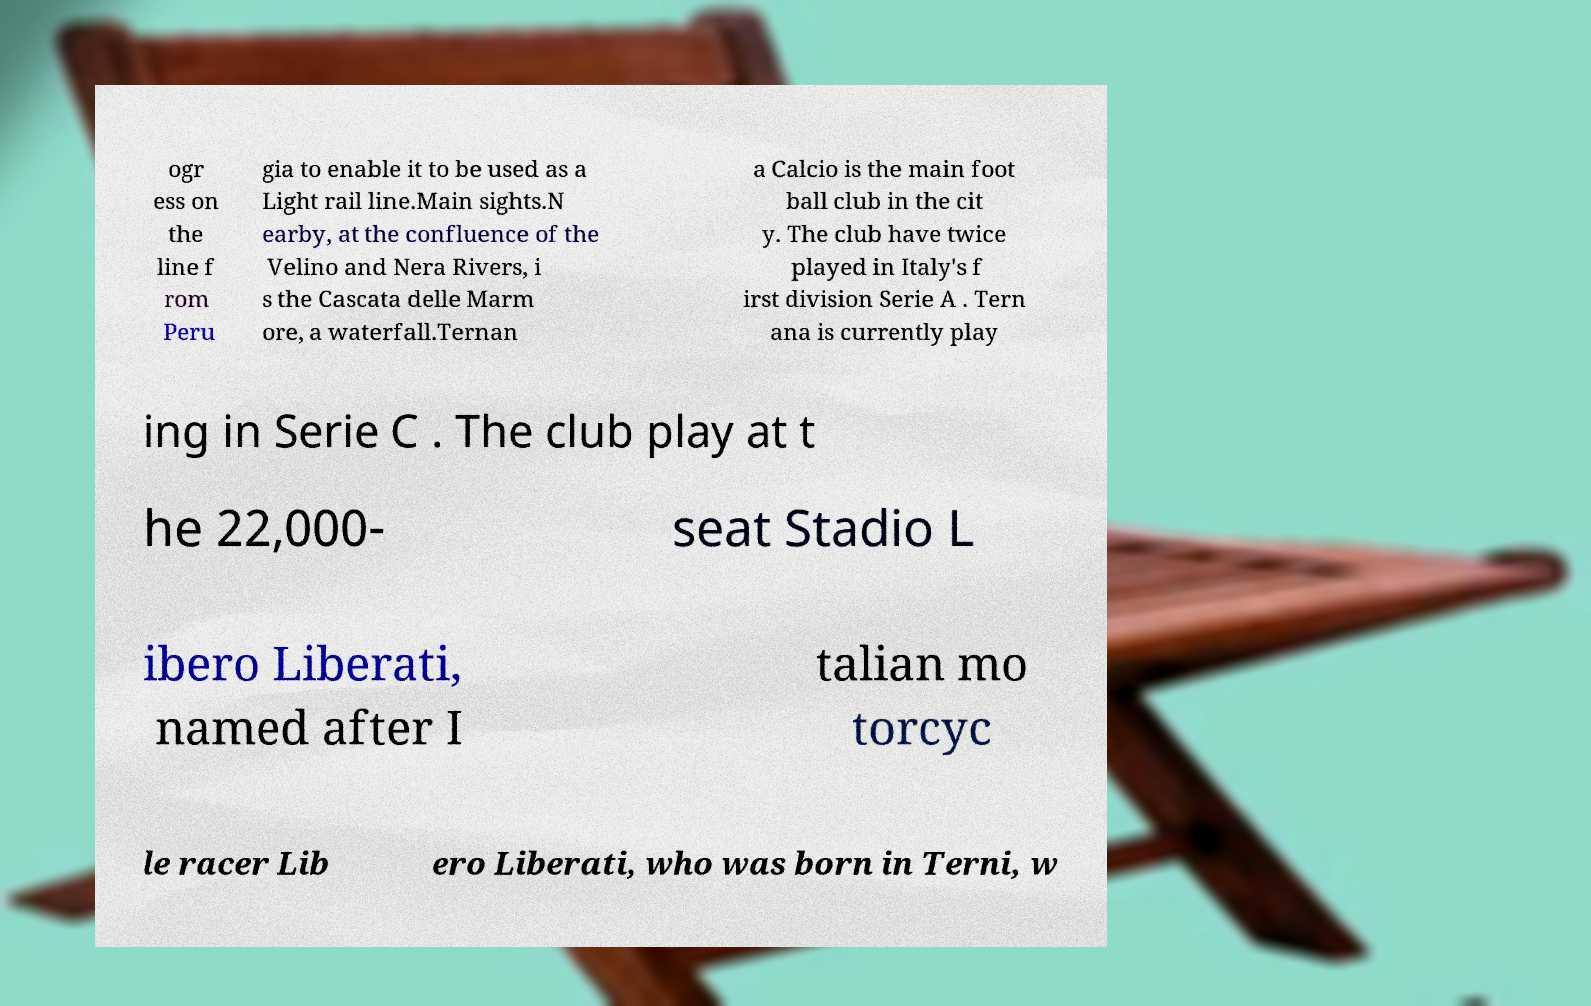I need the written content from this picture converted into text. Can you do that? ogr ess on the line f rom Peru gia to enable it to be used as a Light rail line.Main sights.N earby, at the confluence of the Velino and Nera Rivers, i s the Cascata delle Marm ore, a waterfall.Ternan a Calcio is the main foot ball club in the cit y. The club have twice played in Italy's f irst division Serie A . Tern ana is currently play ing in Serie C . The club play at t he 22,000- seat Stadio L ibero Liberati, named after I talian mo torcyc le racer Lib ero Liberati, who was born in Terni, w 